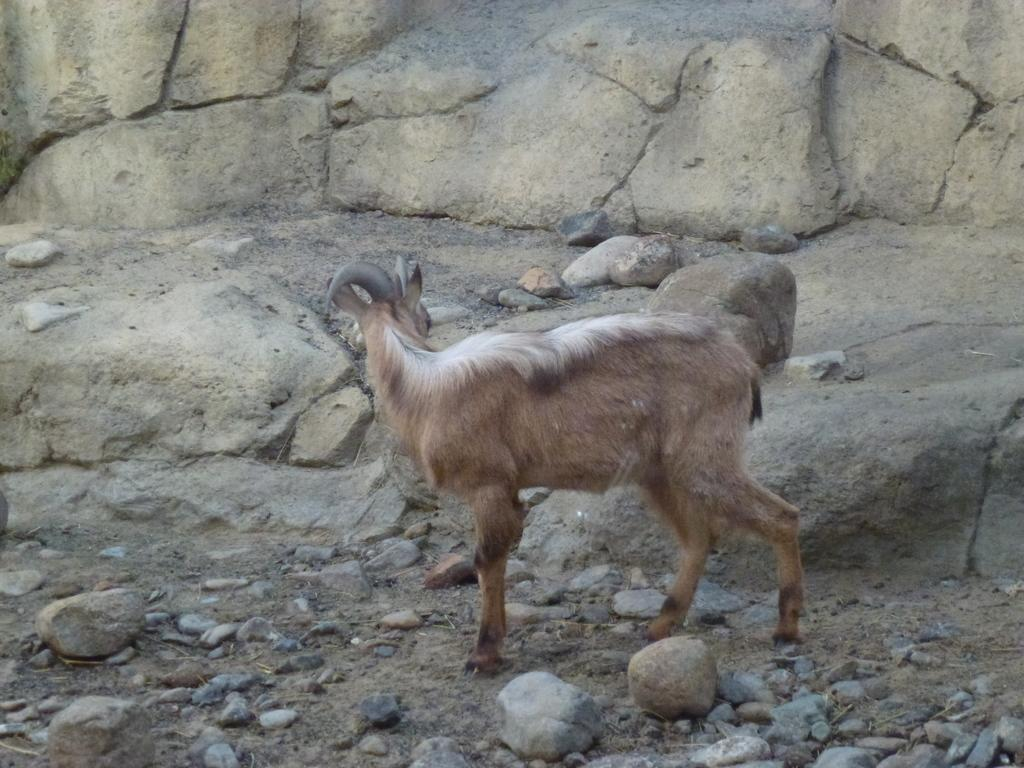What type of living creature is present in the image? There is an animal in the image. What type of natural objects can be seen in the image? There are stones and rocks in the image. How many parcels can be seen in the image? There are no parcels present in the image. What part of the animal's body is visible in the image? The provided facts do not specify any part of the animal's body, so it cannot be determined from the image. 